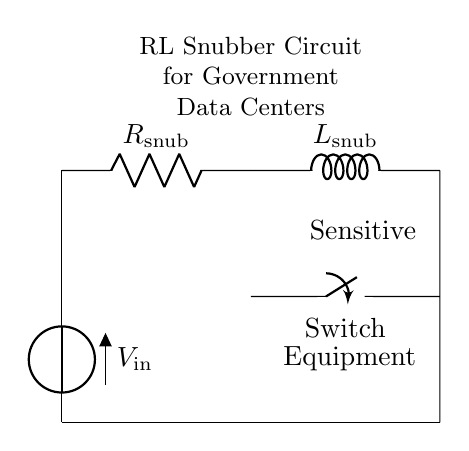What components are present in this circuit? The circuit contains a resistor and an inductor, as indicated by the symbols R and L.
Answer: Resistor and Inductor What is the role of the switch in this circuit? The switch controls the flow of current, allowing or interrupting the connection to the sensitive equipment.
Answer: Control current flow What does the voltage source represent in the circuit? The voltage source represents the input voltage provided to the circuit, denoted as V.
Answer: Input voltage How are the sensitive equipment and the snubber circuit connected? The sensitive equipment is connected in parallel to the inductor, allowing it to receive the voltage when the switch is closed.
Answer: Parallel connection What is the purpose of an RL snubber circuit? The RL snubber circuit is designed to protect sensitive equipment from voltage spikes and transients during switching operations.
Answer: Protect equipment If the switch is closed, which component will experience the immediate effect of voltage change? The inductor will experience the immediate effect of voltage change due to the nature of inductive reactance.
Answer: Inductor 